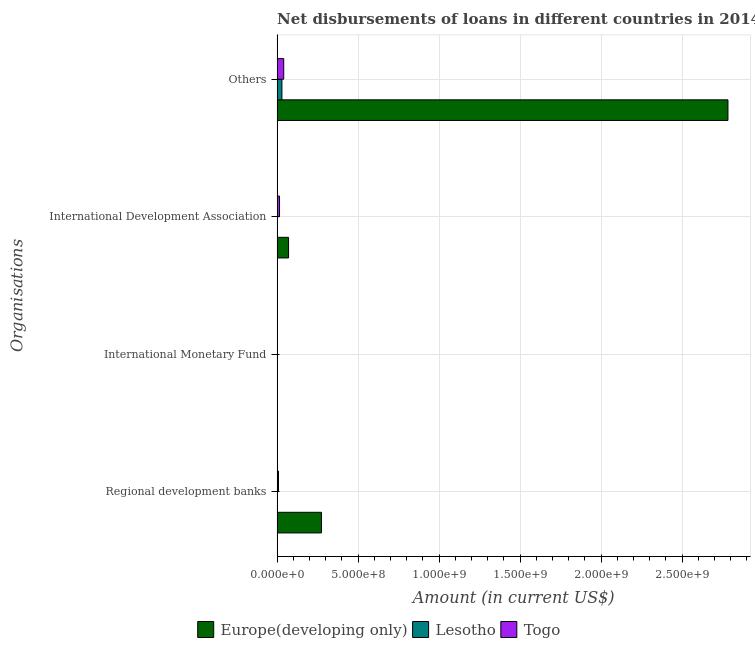How many different coloured bars are there?
Give a very brief answer. 3. Are the number of bars per tick equal to the number of legend labels?
Offer a terse response. No. Are the number of bars on each tick of the Y-axis equal?
Provide a short and direct response. No. How many bars are there on the 1st tick from the top?
Offer a terse response. 3. What is the label of the 4th group of bars from the top?
Give a very brief answer. Regional development banks. Across all countries, what is the maximum amount of loan disimbursed by international development association?
Provide a short and direct response. 7.06e+07. In which country was the amount of loan disimbursed by regional development banks maximum?
Provide a short and direct response. Europe(developing only). What is the total amount of loan disimbursed by regional development banks in the graph?
Give a very brief answer. 2.82e+08. What is the difference between the amount of loan disimbursed by international development association in Lesotho and that in Togo?
Keep it short and to the point. -1.27e+07. What is the difference between the amount of loan disimbursed by international monetary fund in Europe(developing only) and the amount of loan disimbursed by regional development banks in Togo?
Ensure brevity in your answer.  -8.52e+06. What is the average amount of loan disimbursed by international monetary fund per country?
Your response must be concise. 0. What is the difference between the amount of loan disimbursed by other organisations and amount of loan disimbursed by international development association in Europe(developing only)?
Ensure brevity in your answer.  2.71e+09. What is the ratio of the amount of loan disimbursed by other organisations in Europe(developing only) to that in Lesotho?
Keep it short and to the point. 94.01. Is the amount of loan disimbursed by international development association in Europe(developing only) less than that in Togo?
Your answer should be compact. No. Is the difference between the amount of loan disimbursed by other organisations in Europe(developing only) and Togo greater than the difference between the amount of loan disimbursed by regional development banks in Europe(developing only) and Togo?
Your answer should be compact. Yes. What is the difference between the highest and the second highest amount of loan disimbursed by international development association?
Provide a succinct answer. 5.57e+07. What is the difference between the highest and the lowest amount of loan disimbursed by international development association?
Provide a short and direct response. 6.84e+07. Is it the case that in every country, the sum of the amount of loan disimbursed by regional development banks and amount of loan disimbursed by international monetary fund is greater than the amount of loan disimbursed by international development association?
Your answer should be very brief. No. How many bars are there?
Your response must be concise. 8. Are all the bars in the graph horizontal?
Provide a short and direct response. Yes. How many countries are there in the graph?
Provide a succinct answer. 3. Are the values on the major ticks of X-axis written in scientific E-notation?
Your answer should be very brief. Yes. Where does the legend appear in the graph?
Your answer should be compact. Bottom center. How many legend labels are there?
Ensure brevity in your answer.  3. How are the legend labels stacked?
Provide a succinct answer. Horizontal. What is the title of the graph?
Make the answer very short. Net disbursements of loans in different countries in 2014. What is the label or title of the X-axis?
Your answer should be compact. Amount (in current US$). What is the label or title of the Y-axis?
Your answer should be compact. Organisations. What is the Amount (in current US$) of Europe(developing only) in Regional development banks?
Offer a very short reply. 2.73e+08. What is the Amount (in current US$) of Lesotho in Regional development banks?
Your answer should be very brief. 0. What is the Amount (in current US$) of Togo in Regional development banks?
Ensure brevity in your answer.  8.52e+06. What is the Amount (in current US$) of Lesotho in International Monetary Fund?
Give a very brief answer. 0. What is the Amount (in current US$) in Togo in International Monetary Fund?
Make the answer very short. 0. What is the Amount (in current US$) of Europe(developing only) in International Development Association?
Your response must be concise. 7.06e+07. What is the Amount (in current US$) of Lesotho in International Development Association?
Ensure brevity in your answer.  2.20e+06. What is the Amount (in current US$) of Togo in International Development Association?
Offer a very short reply. 1.49e+07. What is the Amount (in current US$) of Europe(developing only) in Others?
Your answer should be compact. 2.78e+09. What is the Amount (in current US$) of Lesotho in Others?
Make the answer very short. 2.96e+07. What is the Amount (in current US$) in Togo in Others?
Keep it short and to the point. 4.07e+07. Across all Organisations, what is the maximum Amount (in current US$) of Europe(developing only)?
Offer a very short reply. 2.78e+09. Across all Organisations, what is the maximum Amount (in current US$) of Lesotho?
Offer a very short reply. 2.96e+07. Across all Organisations, what is the maximum Amount (in current US$) of Togo?
Your answer should be very brief. 4.07e+07. Across all Organisations, what is the minimum Amount (in current US$) in Lesotho?
Make the answer very short. 0. What is the total Amount (in current US$) of Europe(developing only) in the graph?
Give a very brief answer. 3.13e+09. What is the total Amount (in current US$) in Lesotho in the graph?
Ensure brevity in your answer.  3.18e+07. What is the total Amount (in current US$) of Togo in the graph?
Offer a terse response. 6.41e+07. What is the difference between the Amount (in current US$) of Europe(developing only) in Regional development banks and that in International Development Association?
Keep it short and to the point. 2.03e+08. What is the difference between the Amount (in current US$) of Togo in Regional development banks and that in International Development Association?
Your answer should be very brief. -6.37e+06. What is the difference between the Amount (in current US$) in Europe(developing only) in Regional development banks and that in Others?
Keep it short and to the point. -2.51e+09. What is the difference between the Amount (in current US$) of Togo in Regional development banks and that in Others?
Offer a very short reply. -3.22e+07. What is the difference between the Amount (in current US$) of Europe(developing only) in International Development Association and that in Others?
Keep it short and to the point. -2.71e+09. What is the difference between the Amount (in current US$) in Lesotho in International Development Association and that in Others?
Your answer should be compact. -2.74e+07. What is the difference between the Amount (in current US$) of Togo in International Development Association and that in Others?
Ensure brevity in your answer.  -2.58e+07. What is the difference between the Amount (in current US$) of Europe(developing only) in Regional development banks and the Amount (in current US$) of Lesotho in International Development Association?
Your response must be concise. 2.71e+08. What is the difference between the Amount (in current US$) in Europe(developing only) in Regional development banks and the Amount (in current US$) in Togo in International Development Association?
Give a very brief answer. 2.59e+08. What is the difference between the Amount (in current US$) in Europe(developing only) in Regional development banks and the Amount (in current US$) in Lesotho in Others?
Provide a short and direct response. 2.44e+08. What is the difference between the Amount (in current US$) of Europe(developing only) in Regional development banks and the Amount (in current US$) of Togo in Others?
Offer a terse response. 2.33e+08. What is the difference between the Amount (in current US$) of Europe(developing only) in International Development Association and the Amount (in current US$) of Lesotho in Others?
Your answer should be compact. 4.10e+07. What is the difference between the Amount (in current US$) of Europe(developing only) in International Development Association and the Amount (in current US$) of Togo in Others?
Make the answer very short. 2.99e+07. What is the difference between the Amount (in current US$) in Lesotho in International Development Association and the Amount (in current US$) in Togo in Others?
Offer a very short reply. -3.85e+07. What is the average Amount (in current US$) of Europe(developing only) per Organisations?
Your answer should be compact. 7.82e+08. What is the average Amount (in current US$) in Lesotho per Organisations?
Make the answer very short. 7.95e+06. What is the average Amount (in current US$) in Togo per Organisations?
Offer a very short reply. 1.60e+07. What is the difference between the Amount (in current US$) in Europe(developing only) and Amount (in current US$) in Togo in Regional development banks?
Provide a short and direct response. 2.65e+08. What is the difference between the Amount (in current US$) of Europe(developing only) and Amount (in current US$) of Lesotho in International Development Association?
Provide a short and direct response. 6.84e+07. What is the difference between the Amount (in current US$) in Europe(developing only) and Amount (in current US$) in Togo in International Development Association?
Provide a succinct answer. 5.57e+07. What is the difference between the Amount (in current US$) in Lesotho and Amount (in current US$) in Togo in International Development Association?
Make the answer very short. -1.27e+07. What is the difference between the Amount (in current US$) of Europe(developing only) and Amount (in current US$) of Lesotho in Others?
Ensure brevity in your answer.  2.75e+09. What is the difference between the Amount (in current US$) in Europe(developing only) and Amount (in current US$) in Togo in Others?
Give a very brief answer. 2.74e+09. What is the difference between the Amount (in current US$) of Lesotho and Amount (in current US$) of Togo in Others?
Keep it short and to the point. -1.11e+07. What is the ratio of the Amount (in current US$) in Europe(developing only) in Regional development banks to that in International Development Association?
Your answer should be very brief. 3.87. What is the ratio of the Amount (in current US$) in Togo in Regional development banks to that in International Development Association?
Provide a short and direct response. 0.57. What is the ratio of the Amount (in current US$) of Europe(developing only) in Regional development banks to that in Others?
Your response must be concise. 0.1. What is the ratio of the Amount (in current US$) of Togo in Regional development banks to that in Others?
Give a very brief answer. 0.21. What is the ratio of the Amount (in current US$) of Europe(developing only) in International Development Association to that in Others?
Provide a succinct answer. 0.03. What is the ratio of the Amount (in current US$) in Lesotho in International Development Association to that in Others?
Your answer should be very brief. 0.07. What is the ratio of the Amount (in current US$) in Togo in International Development Association to that in Others?
Provide a short and direct response. 0.37. What is the difference between the highest and the second highest Amount (in current US$) in Europe(developing only)?
Provide a succinct answer. 2.51e+09. What is the difference between the highest and the second highest Amount (in current US$) in Togo?
Your response must be concise. 2.58e+07. What is the difference between the highest and the lowest Amount (in current US$) in Europe(developing only)?
Provide a short and direct response. 2.78e+09. What is the difference between the highest and the lowest Amount (in current US$) of Lesotho?
Make the answer very short. 2.96e+07. What is the difference between the highest and the lowest Amount (in current US$) of Togo?
Offer a very short reply. 4.07e+07. 